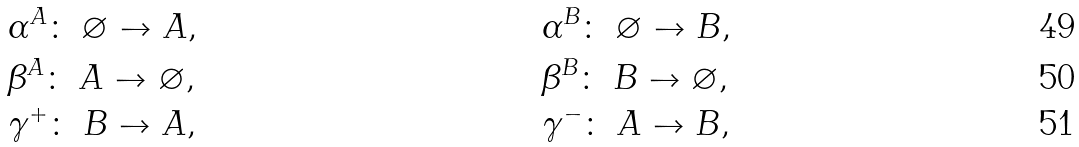<formula> <loc_0><loc_0><loc_500><loc_500>& \alpha ^ { A } \colon \ \varnothing \to A , & & \alpha ^ { B } \colon \ \varnothing \to B , \\ & \beta ^ { A } \colon \ A \to \varnothing , & & \beta ^ { B } \colon \ B \to \varnothing , \\ & \gamma ^ { + } \colon \ B \to A , & & \gamma ^ { - } \colon \ A \to B ,</formula> 